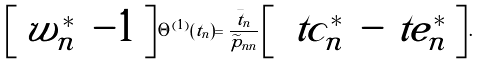Convert formula to latex. <formula><loc_0><loc_0><loc_500><loc_500>\left [ \begin{array} { c c } w _ { n } ^ { * } & - 1 \end{array} \right ] \Theta ^ { ( 1 ) } ( t _ { n } ) = \frac { \bar { t } _ { n } } { \widetilde { p } _ { n n } } \left [ \begin{array} { c c } \ t c _ { n } ^ { * } & - \ t e _ { n } ^ { * } \end{array} \right ] .</formula> 